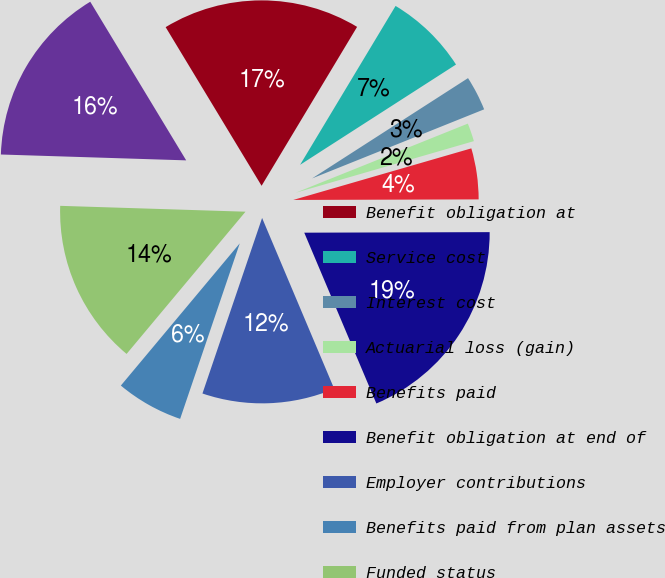<chart> <loc_0><loc_0><loc_500><loc_500><pie_chart><fcel>Benefit obligation at<fcel>Service cost<fcel>Interest cost<fcel>Actuarial loss (gain)<fcel>Benefits paid<fcel>Benefit obligation at end of<fcel>Employer contributions<fcel>Benefits paid from plan assets<fcel>Funded status<fcel>Unrecognized net actuarial<nl><fcel>17.27%<fcel>7.29%<fcel>3.02%<fcel>1.59%<fcel>4.44%<fcel>18.69%<fcel>11.57%<fcel>5.87%<fcel>14.42%<fcel>15.84%<nl></chart> 